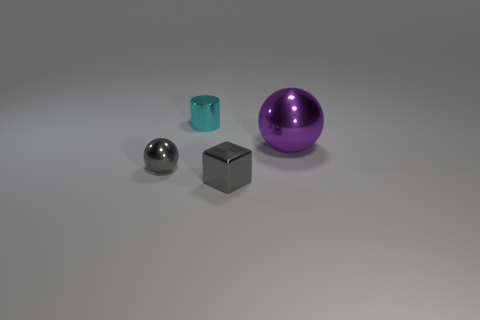What number of other things are there of the same shape as the small cyan object?
Your answer should be very brief. 0. What size is the metallic ball to the right of the cyan metallic cylinder?
Give a very brief answer. Large. How many large shiny balls are on the right side of the sphere behind the small sphere?
Give a very brief answer. 0. What number of other things are the same size as the gray sphere?
Provide a succinct answer. 2. Do the big metal object and the tiny cube have the same color?
Offer a very short reply. No. Do the small object that is behind the large ball and the big metal object have the same shape?
Ensure brevity in your answer.  No. What number of metal spheres are both behind the small gray sphere and left of the small cyan metallic thing?
Provide a succinct answer. 0. What material is the purple sphere?
Make the answer very short. Metal. Are there any other things that have the same color as the tiny metal cylinder?
Your answer should be compact. No. Is the big thing made of the same material as the cube?
Keep it short and to the point. Yes. 